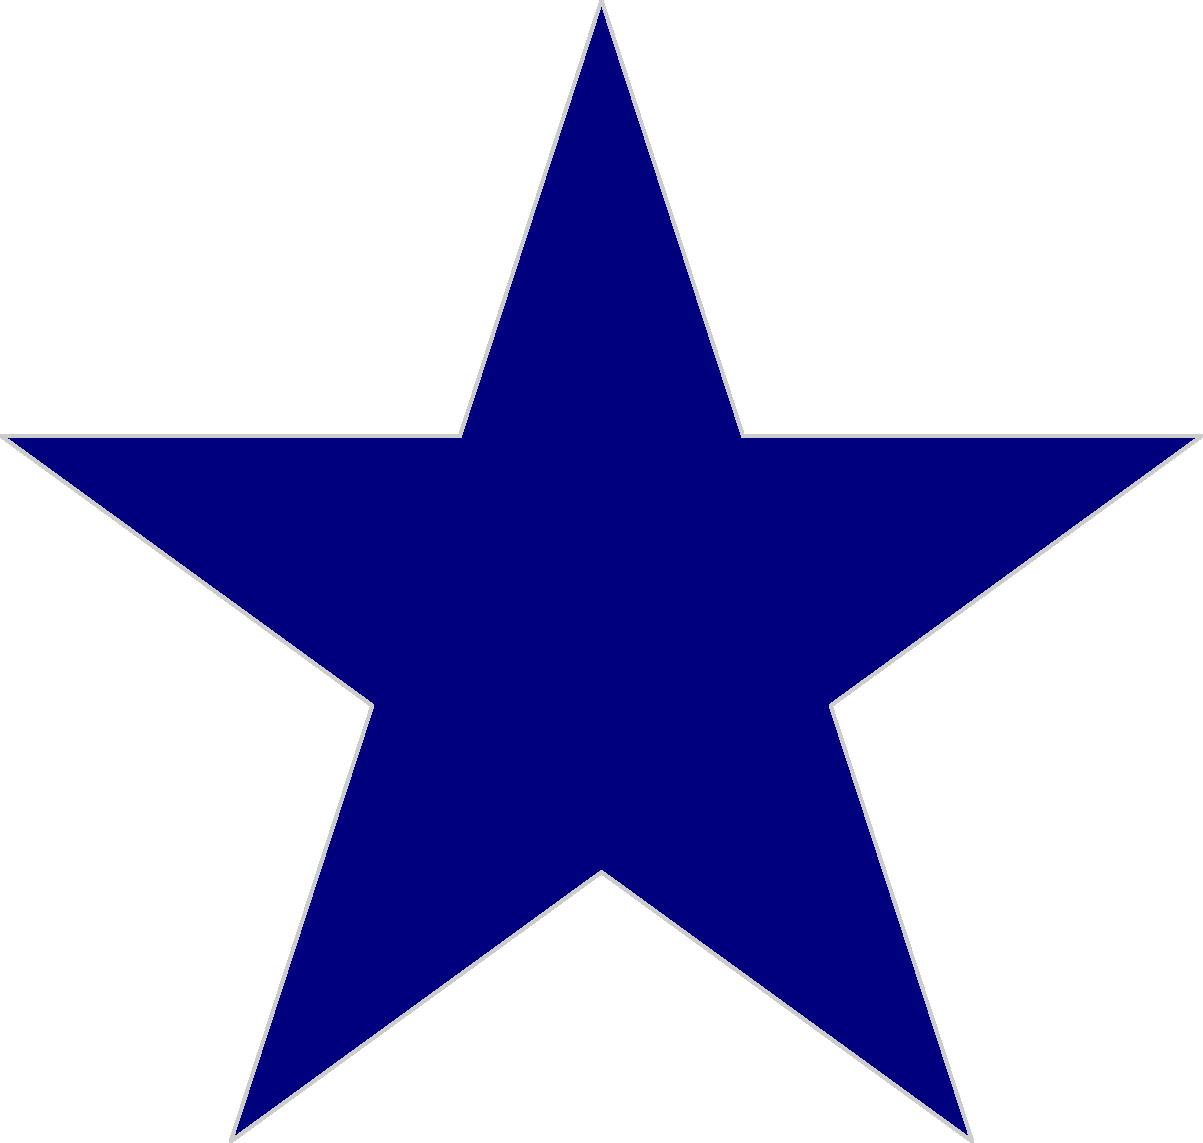Based on this partial logo, which NFL team does this star represent? To identify the NFL team from this partial logo, let's break it down step-by-step:

1. The image shows a blue star with a white outline.
2. The star is a five-pointed star, which is a common symbol in sports logos.
3. In the NFL, there is only one team that prominently features a blue star as its primary logo.
4. This team is known for its iconic star logo, which has remained largely unchanged for decades.
5. The team plays in Texas and is often referred to as "America's Team."
6. The color scheme of blue and white is consistent with this team's official colors.
7. The star is a symbol of the "Lone Star State," which is the nickname for Texas.

Given these clues, especially the blue star being the central element of the logo, this partial image clearly represents the Dallas Cowboys.
Answer: Dallas Cowboys 